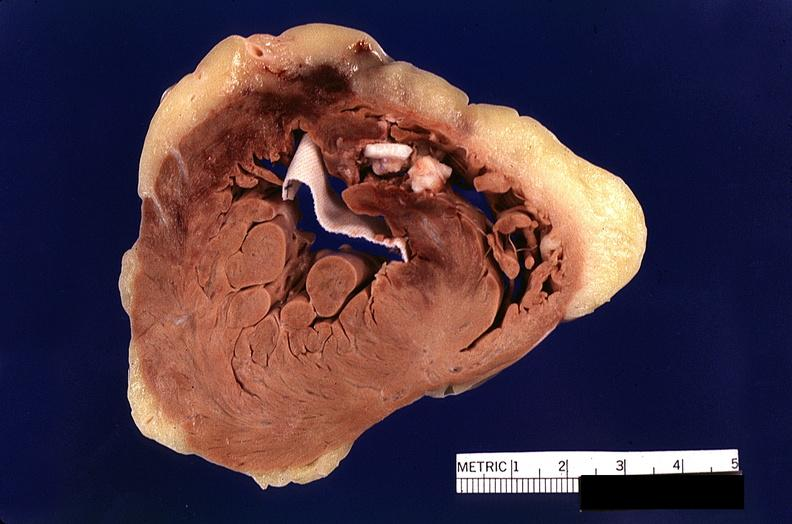s stillborn cord around neck present?
Answer the question using a single word or phrase. No 